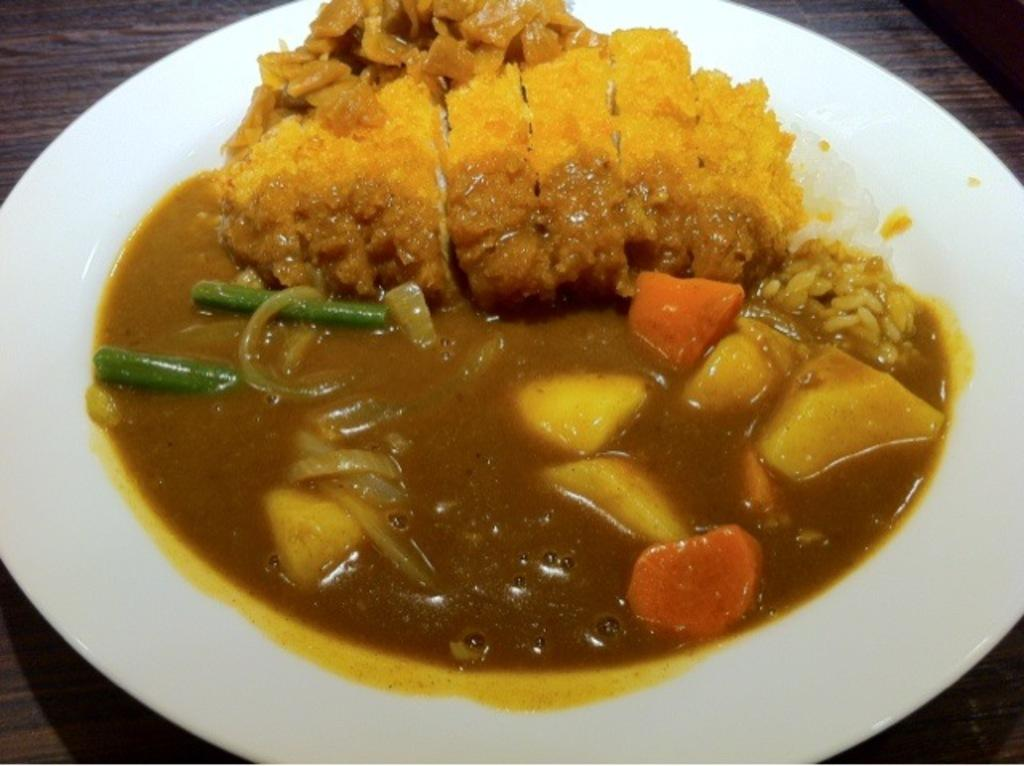What is on the plate that is visible in the image? There is food on a plate in the image. Where is the plate placed in the image? The plate is placed on a wooden table. Can you see any jellyfish swimming in the food on the plate? There are no jellyfish present in the image, and they are not swimming in the food on the plate. Is there a quilt being used as a tablecloth on the wooden table? There is no mention of a quilt or any tablecloth in the image. 